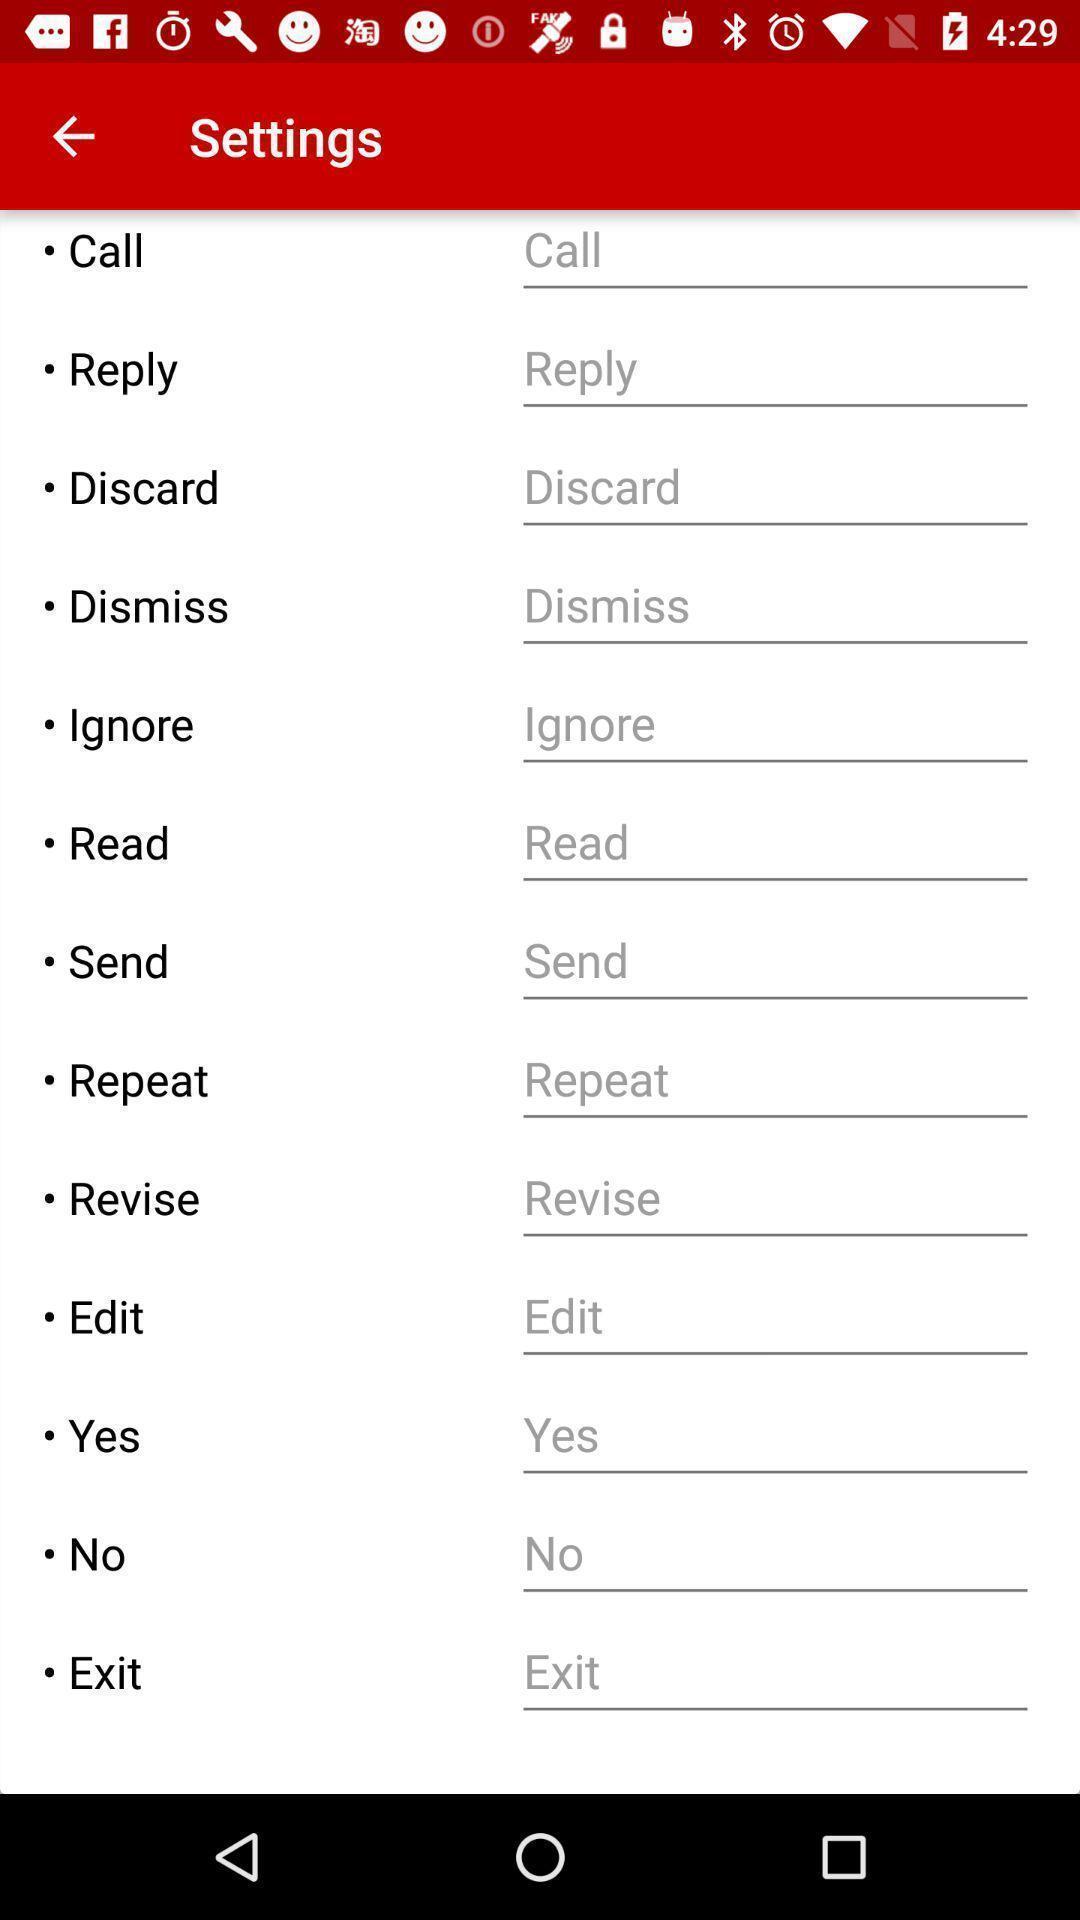Provide a detailed account of this screenshot. Page shows the list of various settings options. 